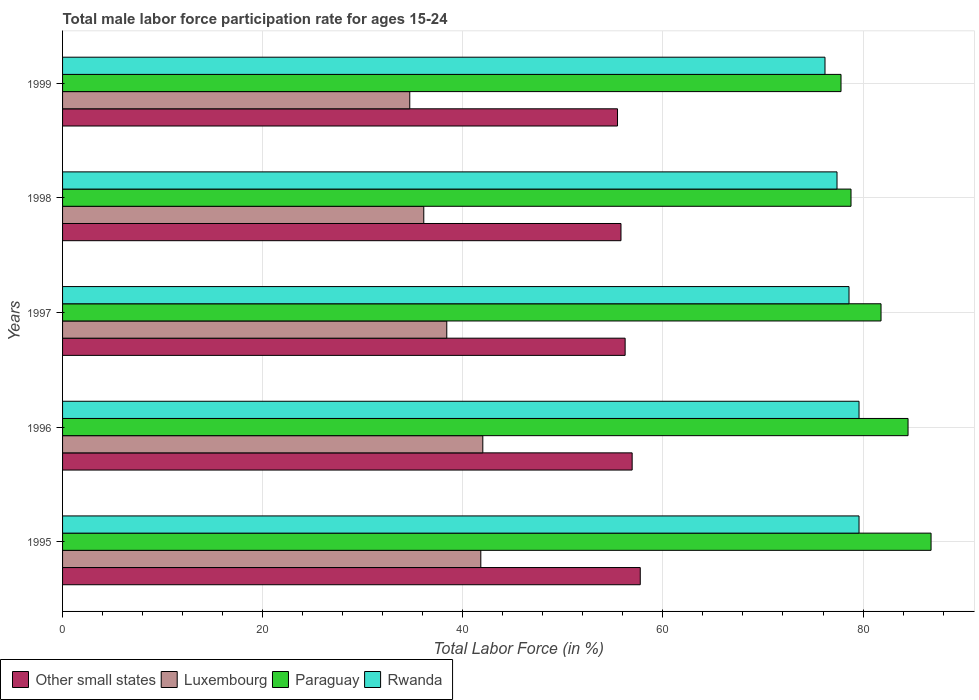How many groups of bars are there?
Provide a succinct answer. 5. Are the number of bars per tick equal to the number of legend labels?
Provide a succinct answer. Yes. How many bars are there on the 1st tick from the bottom?
Keep it short and to the point. 4. What is the label of the 4th group of bars from the top?
Offer a terse response. 1996. What is the male labor force participation rate in Luxembourg in 1999?
Offer a very short reply. 34.7. Across all years, what is the maximum male labor force participation rate in Paraguay?
Offer a very short reply. 86.8. Across all years, what is the minimum male labor force participation rate in Luxembourg?
Provide a succinct answer. 34.7. In which year was the male labor force participation rate in Luxembourg maximum?
Your answer should be compact. 1996. In which year was the male labor force participation rate in Other small states minimum?
Make the answer very short. 1999. What is the total male labor force participation rate in Other small states in the graph?
Offer a very short reply. 282.16. What is the difference between the male labor force participation rate in Other small states in 1995 and that in 1999?
Provide a short and direct response. 2.27. What is the difference between the male labor force participation rate in Other small states in 1997 and the male labor force participation rate in Paraguay in 1999?
Your answer should be very brief. -21.58. What is the average male labor force participation rate in Other small states per year?
Make the answer very short. 56.43. In the year 1995, what is the difference between the male labor force participation rate in Rwanda and male labor force participation rate in Other small states?
Give a very brief answer. 21.86. In how many years, is the male labor force participation rate in Rwanda greater than 16 %?
Give a very brief answer. 5. What is the ratio of the male labor force participation rate in Paraguay in 1995 to that in 1999?
Ensure brevity in your answer.  1.12. Is the male labor force participation rate in Rwanda in 1996 less than that in 1999?
Give a very brief answer. No. What is the difference between the highest and the second highest male labor force participation rate in Other small states?
Offer a very short reply. 0.81. What is the difference between the highest and the lowest male labor force participation rate in Luxembourg?
Provide a succinct answer. 7.3. Is the sum of the male labor force participation rate in Rwanda in 1995 and 1997 greater than the maximum male labor force participation rate in Luxembourg across all years?
Ensure brevity in your answer.  Yes. Is it the case that in every year, the sum of the male labor force participation rate in Other small states and male labor force participation rate in Paraguay is greater than the sum of male labor force participation rate in Rwanda and male labor force participation rate in Luxembourg?
Your response must be concise. Yes. What does the 3rd bar from the top in 1998 represents?
Make the answer very short. Luxembourg. What does the 1st bar from the bottom in 1995 represents?
Your answer should be very brief. Other small states. Is it the case that in every year, the sum of the male labor force participation rate in Other small states and male labor force participation rate in Rwanda is greater than the male labor force participation rate in Paraguay?
Offer a terse response. Yes. Are all the bars in the graph horizontal?
Ensure brevity in your answer.  Yes. What is the difference between two consecutive major ticks on the X-axis?
Provide a succinct answer. 20. Are the values on the major ticks of X-axis written in scientific E-notation?
Keep it short and to the point. No. Does the graph contain grids?
Provide a short and direct response. Yes. How are the legend labels stacked?
Ensure brevity in your answer.  Horizontal. What is the title of the graph?
Give a very brief answer. Total male labor force participation rate for ages 15-24. Does "Papua New Guinea" appear as one of the legend labels in the graph?
Keep it short and to the point. No. What is the label or title of the X-axis?
Keep it short and to the point. Total Labor Force (in %). What is the Total Labor Force (in %) of Other small states in 1995?
Provide a short and direct response. 57.74. What is the Total Labor Force (in %) of Luxembourg in 1995?
Keep it short and to the point. 41.8. What is the Total Labor Force (in %) in Paraguay in 1995?
Your response must be concise. 86.8. What is the Total Labor Force (in %) of Rwanda in 1995?
Your response must be concise. 79.6. What is the Total Labor Force (in %) in Other small states in 1996?
Give a very brief answer. 56.93. What is the Total Labor Force (in %) in Paraguay in 1996?
Your answer should be very brief. 84.5. What is the Total Labor Force (in %) of Rwanda in 1996?
Your answer should be compact. 79.6. What is the Total Labor Force (in %) of Other small states in 1997?
Provide a short and direct response. 56.22. What is the Total Labor Force (in %) of Luxembourg in 1997?
Your answer should be compact. 38.4. What is the Total Labor Force (in %) in Paraguay in 1997?
Your response must be concise. 81.8. What is the Total Labor Force (in %) of Rwanda in 1997?
Provide a succinct answer. 78.6. What is the Total Labor Force (in %) of Other small states in 1998?
Your answer should be compact. 55.81. What is the Total Labor Force (in %) in Luxembourg in 1998?
Keep it short and to the point. 36.1. What is the Total Labor Force (in %) in Paraguay in 1998?
Provide a short and direct response. 78.8. What is the Total Labor Force (in %) in Rwanda in 1998?
Provide a short and direct response. 77.4. What is the Total Labor Force (in %) in Other small states in 1999?
Your answer should be very brief. 55.46. What is the Total Labor Force (in %) in Luxembourg in 1999?
Your answer should be very brief. 34.7. What is the Total Labor Force (in %) in Paraguay in 1999?
Provide a short and direct response. 77.8. What is the Total Labor Force (in %) in Rwanda in 1999?
Ensure brevity in your answer.  76.2. Across all years, what is the maximum Total Labor Force (in %) in Other small states?
Your answer should be very brief. 57.74. Across all years, what is the maximum Total Labor Force (in %) of Luxembourg?
Your response must be concise. 42. Across all years, what is the maximum Total Labor Force (in %) in Paraguay?
Your answer should be very brief. 86.8. Across all years, what is the maximum Total Labor Force (in %) of Rwanda?
Offer a very short reply. 79.6. Across all years, what is the minimum Total Labor Force (in %) in Other small states?
Your answer should be very brief. 55.46. Across all years, what is the minimum Total Labor Force (in %) in Luxembourg?
Make the answer very short. 34.7. Across all years, what is the minimum Total Labor Force (in %) of Paraguay?
Give a very brief answer. 77.8. Across all years, what is the minimum Total Labor Force (in %) in Rwanda?
Give a very brief answer. 76.2. What is the total Total Labor Force (in %) of Other small states in the graph?
Make the answer very short. 282.16. What is the total Total Labor Force (in %) of Luxembourg in the graph?
Make the answer very short. 193. What is the total Total Labor Force (in %) of Paraguay in the graph?
Ensure brevity in your answer.  409.7. What is the total Total Labor Force (in %) of Rwanda in the graph?
Your answer should be compact. 391.4. What is the difference between the Total Labor Force (in %) in Other small states in 1995 and that in 1996?
Provide a short and direct response. 0.81. What is the difference between the Total Labor Force (in %) of Rwanda in 1995 and that in 1996?
Provide a short and direct response. 0. What is the difference between the Total Labor Force (in %) in Other small states in 1995 and that in 1997?
Keep it short and to the point. 1.51. What is the difference between the Total Labor Force (in %) of Paraguay in 1995 and that in 1997?
Your response must be concise. 5. What is the difference between the Total Labor Force (in %) in Rwanda in 1995 and that in 1997?
Provide a short and direct response. 1. What is the difference between the Total Labor Force (in %) in Other small states in 1995 and that in 1998?
Your answer should be compact. 1.93. What is the difference between the Total Labor Force (in %) in Luxembourg in 1995 and that in 1998?
Your answer should be very brief. 5.7. What is the difference between the Total Labor Force (in %) of Other small states in 1995 and that in 1999?
Ensure brevity in your answer.  2.27. What is the difference between the Total Labor Force (in %) in Paraguay in 1995 and that in 1999?
Provide a succinct answer. 9. What is the difference between the Total Labor Force (in %) in Rwanda in 1995 and that in 1999?
Your answer should be very brief. 3.4. What is the difference between the Total Labor Force (in %) in Other small states in 1996 and that in 1997?
Make the answer very short. 0.7. What is the difference between the Total Labor Force (in %) in Luxembourg in 1996 and that in 1997?
Your response must be concise. 3.6. What is the difference between the Total Labor Force (in %) of Paraguay in 1996 and that in 1997?
Ensure brevity in your answer.  2.7. What is the difference between the Total Labor Force (in %) of Rwanda in 1996 and that in 1997?
Ensure brevity in your answer.  1. What is the difference between the Total Labor Force (in %) of Other small states in 1996 and that in 1998?
Your answer should be compact. 1.12. What is the difference between the Total Labor Force (in %) in Paraguay in 1996 and that in 1998?
Make the answer very short. 5.7. What is the difference between the Total Labor Force (in %) of Other small states in 1996 and that in 1999?
Your answer should be compact. 1.46. What is the difference between the Total Labor Force (in %) of Luxembourg in 1996 and that in 1999?
Give a very brief answer. 7.3. What is the difference between the Total Labor Force (in %) in Paraguay in 1996 and that in 1999?
Make the answer very short. 6.7. What is the difference between the Total Labor Force (in %) of Rwanda in 1996 and that in 1999?
Make the answer very short. 3.4. What is the difference between the Total Labor Force (in %) of Other small states in 1997 and that in 1998?
Ensure brevity in your answer.  0.41. What is the difference between the Total Labor Force (in %) in Luxembourg in 1997 and that in 1998?
Ensure brevity in your answer.  2.3. What is the difference between the Total Labor Force (in %) of Paraguay in 1997 and that in 1998?
Make the answer very short. 3. What is the difference between the Total Labor Force (in %) in Rwanda in 1997 and that in 1998?
Provide a short and direct response. 1.2. What is the difference between the Total Labor Force (in %) in Other small states in 1997 and that in 1999?
Offer a terse response. 0.76. What is the difference between the Total Labor Force (in %) of Rwanda in 1997 and that in 1999?
Provide a succinct answer. 2.4. What is the difference between the Total Labor Force (in %) in Other small states in 1998 and that in 1999?
Provide a succinct answer. 0.35. What is the difference between the Total Labor Force (in %) in Paraguay in 1998 and that in 1999?
Offer a terse response. 1. What is the difference between the Total Labor Force (in %) of Other small states in 1995 and the Total Labor Force (in %) of Luxembourg in 1996?
Provide a succinct answer. 15.74. What is the difference between the Total Labor Force (in %) in Other small states in 1995 and the Total Labor Force (in %) in Paraguay in 1996?
Provide a succinct answer. -26.76. What is the difference between the Total Labor Force (in %) of Other small states in 1995 and the Total Labor Force (in %) of Rwanda in 1996?
Offer a very short reply. -21.86. What is the difference between the Total Labor Force (in %) in Luxembourg in 1995 and the Total Labor Force (in %) in Paraguay in 1996?
Give a very brief answer. -42.7. What is the difference between the Total Labor Force (in %) of Luxembourg in 1995 and the Total Labor Force (in %) of Rwanda in 1996?
Give a very brief answer. -37.8. What is the difference between the Total Labor Force (in %) in Other small states in 1995 and the Total Labor Force (in %) in Luxembourg in 1997?
Offer a very short reply. 19.34. What is the difference between the Total Labor Force (in %) in Other small states in 1995 and the Total Labor Force (in %) in Paraguay in 1997?
Ensure brevity in your answer.  -24.06. What is the difference between the Total Labor Force (in %) in Other small states in 1995 and the Total Labor Force (in %) in Rwanda in 1997?
Give a very brief answer. -20.86. What is the difference between the Total Labor Force (in %) of Luxembourg in 1995 and the Total Labor Force (in %) of Paraguay in 1997?
Offer a very short reply. -40. What is the difference between the Total Labor Force (in %) in Luxembourg in 1995 and the Total Labor Force (in %) in Rwanda in 1997?
Your answer should be very brief. -36.8. What is the difference between the Total Labor Force (in %) of Paraguay in 1995 and the Total Labor Force (in %) of Rwanda in 1997?
Your answer should be compact. 8.2. What is the difference between the Total Labor Force (in %) of Other small states in 1995 and the Total Labor Force (in %) of Luxembourg in 1998?
Your answer should be compact. 21.64. What is the difference between the Total Labor Force (in %) of Other small states in 1995 and the Total Labor Force (in %) of Paraguay in 1998?
Your answer should be compact. -21.06. What is the difference between the Total Labor Force (in %) of Other small states in 1995 and the Total Labor Force (in %) of Rwanda in 1998?
Offer a very short reply. -19.66. What is the difference between the Total Labor Force (in %) of Luxembourg in 1995 and the Total Labor Force (in %) of Paraguay in 1998?
Keep it short and to the point. -37. What is the difference between the Total Labor Force (in %) in Luxembourg in 1995 and the Total Labor Force (in %) in Rwanda in 1998?
Make the answer very short. -35.6. What is the difference between the Total Labor Force (in %) in Paraguay in 1995 and the Total Labor Force (in %) in Rwanda in 1998?
Keep it short and to the point. 9.4. What is the difference between the Total Labor Force (in %) of Other small states in 1995 and the Total Labor Force (in %) of Luxembourg in 1999?
Give a very brief answer. 23.04. What is the difference between the Total Labor Force (in %) in Other small states in 1995 and the Total Labor Force (in %) in Paraguay in 1999?
Offer a very short reply. -20.06. What is the difference between the Total Labor Force (in %) of Other small states in 1995 and the Total Labor Force (in %) of Rwanda in 1999?
Your answer should be compact. -18.46. What is the difference between the Total Labor Force (in %) of Luxembourg in 1995 and the Total Labor Force (in %) of Paraguay in 1999?
Ensure brevity in your answer.  -36. What is the difference between the Total Labor Force (in %) of Luxembourg in 1995 and the Total Labor Force (in %) of Rwanda in 1999?
Make the answer very short. -34.4. What is the difference between the Total Labor Force (in %) in Paraguay in 1995 and the Total Labor Force (in %) in Rwanda in 1999?
Provide a short and direct response. 10.6. What is the difference between the Total Labor Force (in %) in Other small states in 1996 and the Total Labor Force (in %) in Luxembourg in 1997?
Keep it short and to the point. 18.53. What is the difference between the Total Labor Force (in %) in Other small states in 1996 and the Total Labor Force (in %) in Paraguay in 1997?
Your answer should be compact. -24.87. What is the difference between the Total Labor Force (in %) of Other small states in 1996 and the Total Labor Force (in %) of Rwanda in 1997?
Offer a very short reply. -21.67. What is the difference between the Total Labor Force (in %) in Luxembourg in 1996 and the Total Labor Force (in %) in Paraguay in 1997?
Give a very brief answer. -39.8. What is the difference between the Total Labor Force (in %) in Luxembourg in 1996 and the Total Labor Force (in %) in Rwanda in 1997?
Your response must be concise. -36.6. What is the difference between the Total Labor Force (in %) of Other small states in 1996 and the Total Labor Force (in %) of Luxembourg in 1998?
Your answer should be very brief. 20.83. What is the difference between the Total Labor Force (in %) in Other small states in 1996 and the Total Labor Force (in %) in Paraguay in 1998?
Provide a short and direct response. -21.87. What is the difference between the Total Labor Force (in %) in Other small states in 1996 and the Total Labor Force (in %) in Rwanda in 1998?
Your answer should be very brief. -20.47. What is the difference between the Total Labor Force (in %) in Luxembourg in 1996 and the Total Labor Force (in %) in Paraguay in 1998?
Offer a terse response. -36.8. What is the difference between the Total Labor Force (in %) in Luxembourg in 1996 and the Total Labor Force (in %) in Rwanda in 1998?
Provide a succinct answer. -35.4. What is the difference between the Total Labor Force (in %) in Other small states in 1996 and the Total Labor Force (in %) in Luxembourg in 1999?
Offer a very short reply. 22.23. What is the difference between the Total Labor Force (in %) in Other small states in 1996 and the Total Labor Force (in %) in Paraguay in 1999?
Offer a very short reply. -20.87. What is the difference between the Total Labor Force (in %) in Other small states in 1996 and the Total Labor Force (in %) in Rwanda in 1999?
Provide a succinct answer. -19.27. What is the difference between the Total Labor Force (in %) of Luxembourg in 1996 and the Total Labor Force (in %) of Paraguay in 1999?
Make the answer very short. -35.8. What is the difference between the Total Labor Force (in %) in Luxembourg in 1996 and the Total Labor Force (in %) in Rwanda in 1999?
Provide a succinct answer. -34.2. What is the difference between the Total Labor Force (in %) of Other small states in 1997 and the Total Labor Force (in %) of Luxembourg in 1998?
Offer a terse response. 20.12. What is the difference between the Total Labor Force (in %) in Other small states in 1997 and the Total Labor Force (in %) in Paraguay in 1998?
Your response must be concise. -22.58. What is the difference between the Total Labor Force (in %) of Other small states in 1997 and the Total Labor Force (in %) of Rwanda in 1998?
Your response must be concise. -21.18. What is the difference between the Total Labor Force (in %) of Luxembourg in 1997 and the Total Labor Force (in %) of Paraguay in 1998?
Your response must be concise. -40.4. What is the difference between the Total Labor Force (in %) in Luxembourg in 1997 and the Total Labor Force (in %) in Rwanda in 1998?
Offer a terse response. -39. What is the difference between the Total Labor Force (in %) of Paraguay in 1997 and the Total Labor Force (in %) of Rwanda in 1998?
Keep it short and to the point. 4.4. What is the difference between the Total Labor Force (in %) of Other small states in 1997 and the Total Labor Force (in %) of Luxembourg in 1999?
Offer a very short reply. 21.52. What is the difference between the Total Labor Force (in %) of Other small states in 1997 and the Total Labor Force (in %) of Paraguay in 1999?
Keep it short and to the point. -21.58. What is the difference between the Total Labor Force (in %) of Other small states in 1997 and the Total Labor Force (in %) of Rwanda in 1999?
Offer a terse response. -19.98. What is the difference between the Total Labor Force (in %) in Luxembourg in 1997 and the Total Labor Force (in %) in Paraguay in 1999?
Keep it short and to the point. -39.4. What is the difference between the Total Labor Force (in %) in Luxembourg in 1997 and the Total Labor Force (in %) in Rwanda in 1999?
Your answer should be very brief. -37.8. What is the difference between the Total Labor Force (in %) of Paraguay in 1997 and the Total Labor Force (in %) of Rwanda in 1999?
Offer a terse response. 5.6. What is the difference between the Total Labor Force (in %) of Other small states in 1998 and the Total Labor Force (in %) of Luxembourg in 1999?
Provide a short and direct response. 21.11. What is the difference between the Total Labor Force (in %) of Other small states in 1998 and the Total Labor Force (in %) of Paraguay in 1999?
Your answer should be very brief. -21.99. What is the difference between the Total Labor Force (in %) of Other small states in 1998 and the Total Labor Force (in %) of Rwanda in 1999?
Provide a succinct answer. -20.39. What is the difference between the Total Labor Force (in %) in Luxembourg in 1998 and the Total Labor Force (in %) in Paraguay in 1999?
Provide a short and direct response. -41.7. What is the difference between the Total Labor Force (in %) in Luxembourg in 1998 and the Total Labor Force (in %) in Rwanda in 1999?
Offer a terse response. -40.1. What is the average Total Labor Force (in %) of Other small states per year?
Your answer should be very brief. 56.43. What is the average Total Labor Force (in %) in Luxembourg per year?
Offer a terse response. 38.6. What is the average Total Labor Force (in %) in Paraguay per year?
Keep it short and to the point. 81.94. What is the average Total Labor Force (in %) of Rwanda per year?
Your answer should be very brief. 78.28. In the year 1995, what is the difference between the Total Labor Force (in %) of Other small states and Total Labor Force (in %) of Luxembourg?
Make the answer very short. 15.94. In the year 1995, what is the difference between the Total Labor Force (in %) of Other small states and Total Labor Force (in %) of Paraguay?
Your answer should be compact. -29.06. In the year 1995, what is the difference between the Total Labor Force (in %) of Other small states and Total Labor Force (in %) of Rwanda?
Offer a very short reply. -21.86. In the year 1995, what is the difference between the Total Labor Force (in %) in Luxembourg and Total Labor Force (in %) in Paraguay?
Keep it short and to the point. -45. In the year 1995, what is the difference between the Total Labor Force (in %) in Luxembourg and Total Labor Force (in %) in Rwanda?
Make the answer very short. -37.8. In the year 1996, what is the difference between the Total Labor Force (in %) of Other small states and Total Labor Force (in %) of Luxembourg?
Give a very brief answer. 14.93. In the year 1996, what is the difference between the Total Labor Force (in %) of Other small states and Total Labor Force (in %) of Paraguay?
Offer a very short reply. -27.57. In the year 1996, what is the difference between the Total Labor Force (in %) in Other small states and Total Labor Force (in %) in Rwanda?
Keep it short and to the point. -22.67. In the year 1996, what is the difference between the Total Labor Force (in %) of Luxembourg and Total Labor Force (in %) of Paraguay?
Keep it short and to the point. -42.5. In the year 1996, what is the difference between the Total Labor Force (in %) in Luxembourg and Total Labor Force (in %) in Rwanda?
Ensure brevity in your answer.  -37.6. In the year 1996, what is the difference between the Total Labor Force (in %) of Paraguay and Total Labor Force (in %) of Rwanda?
Provide a succinct answer. 4.9. In the year 1997, what is the difference between the Total Labor Force (in %) in Other small states and Total Labor Force (in %) in Luxembourg?
Provide a short and direct response. 17.82. In the year 1997, what is the difference between the Total Labor Force (in %) in Other small states and Total Labor Force (in %) in Paraguay?
Offer a very short reply. -25.58. In the year 1997, what is the difference between the Total Labor Force (in %) of Other small states and Total Labor Force (in %) of Rwanda?
Your answer should be very brief. -22.38. In the year 1997, what is the difference between the Total Labor Force (in %) in Luxembourg and Total Labor Force (in %) in Paraguay?
Provide a short and direct response. -43.4. In the year 1997, what is the difference between the Total Labor Force (in %) of Luxembourg and Total Labor Force (in %) of Rwanda?
Provide a short and direct response. -40.2. In the year 1997, what is the difference between the Total Labor Force (in %) of Paraguay and Total Labor Force (in %) of Rwanda?
Ensure brevity in your answer.  3.2. In the year 1998, what is the difference between the Total Labor Force (in %) in Other small states and Total Labor Force (in %) in Luxembourg?
Provide a short and direct response. 19.71. In the year 1998, what is the difference between the Total Labor Force (in %) in Other small states and Total Labor Force (in %) in Paraguay?
Keep it short and to the point. -22.99. In the year 1998, what is the difference between the Total Labor Force (in %) of Other small states and Total Labor Force (in %) of Rwanda?
Your response must be concise. -21.59. In the year 1998, what is the difference between the Total Labor Force (in %) in Luxembourg and Total Labor Force (in %) in Paraguay?
Make the answer very short. -42.7. In the year 1998, what is the difference between the Total Labor Force (in %) of Luxembourg and Total Labor Force (in %) of Rwanda?
Keep it short and to the point. -41.3. In the year 1999, what is the difference between the Total Labor Force (in %) in Other small states and Total Labor Force (in %) in Luxembourg?
Offer a terse response. 20.76. In the year 1999, what is the difference between the Total Labor Force (in %) in Other small states and Total Labor Force (in %) in Paraguay?
Provide a short and direct response. -22.34. In the year 1999, what is the difference between the Total Labor Force (in %) in Other small states and Total Labor Force (in %) in Rwanda?
Your response must be concise. -20.74. In the year 1999, what is the difference between the Total Labor Force (in %) in Luxembourg and Total Labor Force (in %) in Paraguay?
Your answer should be compact. -43.1. In the year 1999, what is the difference between the Total Labor Force (in %) of Luxembourg and Total Labor Force (in %) of Rwanda?
Your answer should be compact. -41.5. In the year 1999, what is the difference between the Total Labor Force (in %) of Paraguay and Total Labor Force (in %) of Rwanda?
Give a very brief answer. 1.6. What is the ratio of the Total Labor Force (in %) in Other small states in 1995 to that in 1996?
Your response must be concise. 1.01. What is the ratio of the Total Labor Force (in %) in Paraguay in 1995 to that in 1996?
Keep it short and to the point. 1.03. What is the ratio of the Total Labor Force (in %) of Rwanda in 1995 to that in 1996?
Give a very brief answer. 1. What is the ratio of the Total Labor Force (in %) in Other small states in 1995 to that in 1997?
Make the answer very short. 1.03. What is the ratio of the Total Labor Force (in %) of Luxembourg in 1995 to that in 1997?
Offer a terse response. 1.09. What is the ratio of the Total Labor Force (in %) in Paraguay in 1995 to that in 1997?
Your response must be concise. 1.06. What is the ratio of the Total Labor Force (in %) in Rwanda in 1995 to that in 1997?
Keep it short and to the point. 1.01. What is the ratio of the Total Labor Force (in %) of Other small states in 1995 to that in 1998?
Give a very brief answer. 1.03. What is the ratio of the Total Labor Force (in %) in Luxembourg in 1995 to that in 1998?
Offer a very short reply. 1.16. What is the ratio of the Total Labor Force (in %) of Paraguay in 1995 to that in 1998?
Provide a succinct answer. 1.1. What is the ratio of the Total Labor Force (in %) in Rwanda in 1995 to that in 1998?
Your response must be concise. 1.03. What is the ratio of the Total Labor Force (in %) of Other small states in 1995 to that in 1999?
Keep it short and to the point. 1.04. What is the ratio of the Total Labor Force (in %) of Luxembourg in 1995 to that in 1999?
Make the answer very short. 1.2. What is the ratio of the Total Labor Force (in %) of Paraguay in 1995 to that in 1999?
Give a very brief answer. 1.12. What is the ratio of the Total Labor Force (in %) of Rwanda in 1995 to that in 1999?
Your answer should be compact. 1.04. What is the ratio of the Total Labor Force (in %) of Other small states in 1996 to that in 1997?
Make the answer very short. 1.01. What is the ratio of the Total Labor Force (in %) of Luxembourg in 1996 to that in 1997?
Your response must be concise. 1.09. What is the ratio of the Total Labor Force (in %) in Paraguay in 1996 to that in 1997?
Your answer should be compact. 1.03. What is the ratio of the Total Labor Force (in %) in Rwanda in 1996 to that in 1997?
Give a very brief answer. 1.01. What is the ratio of the Total Labor Force (in %) in Luxembourg in 1996 to that in 1998?
Provide a succinct answer. 1.16. What is the ratio of the Total Labor Force (in %) in Paraguay in 1996 to that in 1998?
Offer a terse response. 1.07. What is the ratio of the Total Labor Force (in %) of Rwanda in 1996 to that in 1998?
Your answer should be compact. 1.03. What is the ratio of the Total Labor Force (in %) of Other small states in 1996 to that in 1999?
Offer a very short reply. 1.03. What is the ratio of the Total Labor Force (in %) in Luxembourg in 1996 to that in 1999?
Provide a short and direct response. 1.21. What is the ratio of the Total Labor Force (in %) of Paraguay in 1996 to that in 1999?
Offer a very short reply. 1.09. What is the ratio of the Total Labor Force (in %) in Rwanda in 1996 to that in 1999?
Give a very brief answer. 1.04. What is the ratio of the Total Labor Force (in %) of Other small states in 1997 to that in 1998?
Provide a succinct answer. 1.01. What is the ratio of the Total Labor Force (in %) in Luxembourg in 1997 to that in 1998?
Your answer should be very brief. 1.06. What is the ratio of the Total Labor Force (in %) in Paraguay in 1997 to that in 1998?
Provide a succinct answer. 1.04. What is the ratio of the Total Labor Force (in %) in Rwanda in 1997 to that in 1998?
Give a very brief answer. 1.02. What is the ratio of the Total Labor Force (in %) of Other small states in 1997 to that in 1999?
Keep it short and to the point. 1.01. What is the ratio of the Total Labor Force (in %) of Luxembourg in 1997 to that in 1999?
Keep it short and to the point. 1.11. What is the ratio of the Total Labor Force (in %) in Paraguay in 1997 to that in 1999?
Offer a very short reply. 1.05. What is the ratio of the Total Labor Force (in %) of Rwanda in 1997 to that in 1999?
Ensure brevity in your answer.  1.03. What is the ratio of the Total Labor Force (in %) of Luxembourg in 1998 to that in 1999?
Give a very brief answer. 1.04. What is the ratio of the Total Labor Force (in %) of Paraguay in 1998 to that in 1999?
Your answer should be compact. 1.01. What is the ratio of the Total Labor Force (in %) in Rwanda in 1998 to that in 1999?
Keep it short and to the point. 1.02. What is the difference between the highest and the second highest Total Labor Force (in %) of Other small states?
Provide a succinct answer. 0.81. What is the difference between the highest and the second highest Total Labor Force (in %) of Rwanda?
Ensure brevity in your answer.  0. What is the difference between the highest and the lowest Total Labor Force (in %) of Other small states?
Offer a very short reply. 2.27. 